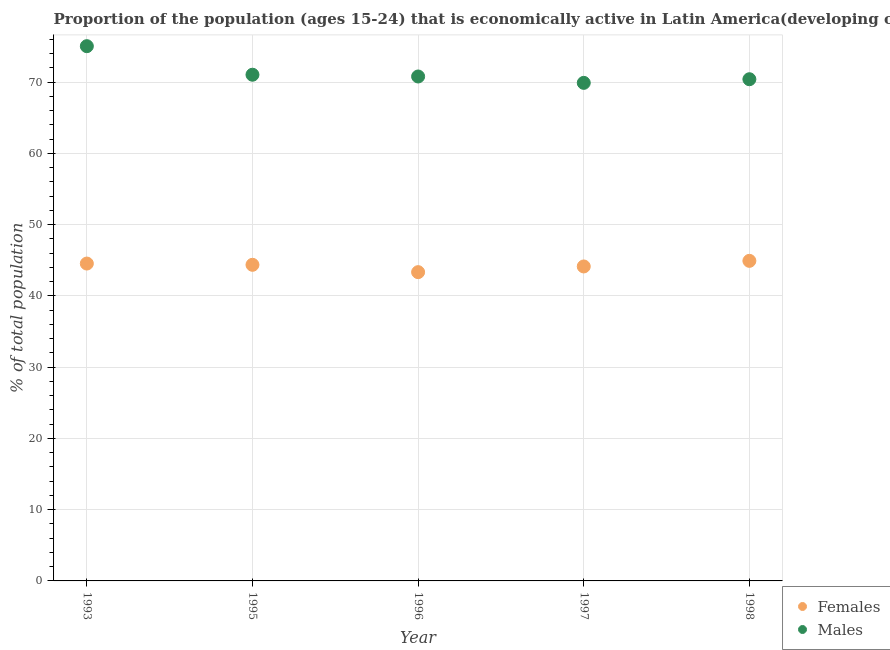How many different coloured dotlines are there?
Your response must be concise. 2. What is the percentage of economically active male population in 1998?
Provide a succinct answer. 70.42. Across all years, what is the maximum percentage of economically active female population?
Your response must be concise. 44.93. Across all years, what is the minimum percentage of economically active male population?
Make the answer very short. 69.91. In which year was the percentage of economically active female population maximum?
Keep it short and to the point. 1998. What is the total percentage of economically active male population in the graph?
Offer a terse response. 357.25. What is the difference between the percentage of economically active female population in 1995 and that in 1997?
Your answer should be very brief. 0.23. What is the difference between the percentage of economically active female population in 1993 and the percentage of economically active male population in 1998?
Your response must be concise. -25.87. What is the average percentage of economically active female population per year?
Your response must be concise. 44.27. In the year 1995, what is the difference between the percentage of economically active female population and percentage of economically active male population?
Your answer should be compact. -26.68. In how many years, is the percentage of economically active female population greater than 12 %?
Offer a terse response. 5. What is the ratio of the percentage of economically active female population in 1997 to that in 1998?
Provide a succinct answer. 0.98. Is the percentage of economically active female population in 1997 less than that in 1998?
Your answer should be very brief. Yes. Is the difference between the percentage of economically active male population in 1993 and 1998 greater than the difference between the percentage of economically active female population in 1993 and 1998?
Give a very brief answer. Yes. What is the difference between the highest and the second highest percentage of economically active male population?
Make the answer very short. 4.01. What is the difference between the highest and the lowest percentage of economically active male population?
Provide a succinct answer. 5.15. Is the sum of the percentage of economically active male population in 1993 and 1996 greater than the maximum percentage of economically active female population across all years?
Make the answer very short. Yes. How many years are there in the graph?
Provide a short and direct response. 5. Does the graph contain any zero values?
Your answer should be very brief. No. Where does the legend appear in the graph?
Give a very brief answer. Bottom right. How are the legend labels stacked?
Give a very brief answer. Vertical. What is the title of the graph?
Keep it short and to the point. Proportion of the population (ages 15-24) that is economically active in Latin America(developing only). Does "Crop" appear as one of the legend labels in the graph?
Give a very brief answer. No. What is the label or title of the Y-axis?
Give a very brief answer. % of total population. What is the % of total population of Females in 1993?
Ensure brevity in your answer.  44.55. What is the % of total population in Males in 1993?
Offer a very short reply. 75.06. What is the % of total population of Females in 1995?
Give a very brief answer. 44.37. What is the % of total population in Males in 1995?
Ensure brevity in your answer.  71.05. What is the % of total population of Females in 1996?
Ensure brevity in your answer.  43.34. What is the % of total population in Males in 1996?
Your answer should be compact. 70.8. What is the % of total population of Females in 1997?
Give a very brief answer. 44.14. What is the % of total population in Males in 1997?
Offer a very short reply. 69.91. What is the % of total population in Females in 1998?
Offer a very short reply. 44.93. What is the % of total population of Males in 1998?
Keep it short and to the point. 70.42. Across all years, what is the maximum % of total population of Females?
Make the answer very short. 44.93. Across all years, what is the maximum % of total population in Males?
Provide a succinct answer. 75.06. Across all years, what is the minimum % of total population of Females?
Ensure brevity in your answer.  43.34. Across all years, what is the minimum % of total population of Males?
Ensure brevity in your answer.  69.91. What is the total % of total population in Females in the graph?
Your response must be concise. 221.33. What is the total % of total population in Males in the graph?
Offer a very short reply. 357.25. What is the difference between the % of total population of Females in 1993 and that in 1995?
Make the answer very short. 0.18. What is the difference between the % of total population in Males in 1993 and that in 1995?
Your answer should be very brief. 4.01. What is the difference between the % of total population of Females in 1993 and that in 1996?
Your answer should be compact. 1.21. What is the difference between the % of total population of Males in 1993 and that in 1996?
Your answer should be compact. 4.25. What is the difference between the % of total population in Females in 1993 and that in 1997?
Keep it short and to the point. 0.41. What is the difference between the % of total population in Males in 1993 and that in 1997?
Offer a very short reply. 5.15. What is the difference between the % of total population of Females in 1993 and that in 1998?
Keep it short and to the point. -0.38. What is the difference between the % of total population of Males in 1993 and that in 1998?
Offer a terse response. 4.64. What is the difference between the % of total population of Females in 1995 and that in 1996?
Give a very brief answer. 1.03. What is the difference between the % of total population of Males in 1995 and that in 1996?
Your answer should be compact. 0.25. What is the difference between the % of total population of Females in 1995 and that in 1997?
Keep it short and to the point. 0.23. What is the difference between the % of total population of Males in 1995 and that in 1997?
Offer a terse response. 1.14. What is the difference between the % of total population in Females in 1995 and that in 1998?
Provide a short and direct response. -0.55. What is the difference between the % of total population of Males in 1995 and that in 1998?
Offer a terse response. 0.63. What is the difference between the % of total population of Females in 1996 and that in 1997?
Your answer should be very brief. -0.8. What is the difference between the % of total population in Males in 1996 and that in 1997?
Make the answer very short. 0.9. What is the difference between the % of total population of Females in 1996 and that in 1998?
Make the answer very short. -1.58. What is the difference between the % of total population of Males in 1996 and that in 1998?
Provide a short and direct response. 0.38. What is the difference between the % of total population of Females in 1997 and that in 1998?
Your answer should be compact. -0.79. What is the difference between the % of total population of Males in 1997 and that in 1998?
Make the answer very short. -0.51. What is the difference between the % of total population of Females in 1993 and the % of total population of Males in 1995?
Your answer should be compact. -26.5. What is the difference between the % of total population of Females in 1993 and the % of total population of Males in 1996?
Ensure brevity in your answer.  -26.26. What is the difference between the % of total population in Females in 1993 and the % of total population in Males in 1997?
Your answer should be very brief. -25.36. What is the difference between the % of total population of Females in 1993 and the % of total population of Males in 1998?
Make the answer very short. -25.87. What is the difference between the % of total population of Females in 1995 and the % of total population of Males in 1996?
Make the answer very short. -26.43. What is the difference between the % of total population of Females in 1995 and the % of total population of Males in 1997?
Make the answer very short. -25.54. What is the difference between the % of total population of Females in 1995 and the % of total population of Males in 1998?
Your answer should be compact. -26.05. What is the difference between the % of total population in Females in 1996 and the % of total population in Males in 1997?
Provide a short and direct response. -26.57. What is the difference between the % of total population of Females in 1996 and the % of total population of Males in 1998?
Your response must be concise. -27.08. What is the difference between the % of total population of Females in 1997 and the % of total population of Males in 1998?
Provide a short and direct response. -26.28. What is the average % of total population of Females per year?
Provide a short and direct response. 44.27. What is the average % of total population of Males per year?
Ensure brevity in your answer.  71.45. In the year 1993, what is the difference between the % of total population of Females and % of total population of Males?
Provide a succinct answer. -30.51. In the year 1995, what is the difference between the % of total population of Females and % of total population of Males?
Provide a succinct answer. -26.68. In the year 1996, what is the difference between the % of total population in Females and % of total population in Males?
Your answer should be compact. -27.46. In the year 1997, what is the difference between the % of total population of Females and % of total population of Males?
Make the answer very short. -25.77. In the year 1998, what is the difference between the % of total population in Females and % of total population in Males?
Offer a very short reply. -25.49. What is the ratio of the % of total population of Males in 1993 to that in 1995?
Give a very brief answer. 1.06. What is the ratio of the % of total population in Females in 1993 to that in 1996?
Your answer should be compact. 1.03. What is the ratio of the % of total population in Males in 1993 to that in 1996?
Keep it short and to the point. 1.06. What is the ratio of the % of total population of Females in 1993 to that in 1997?
Ensure brevity in your answer.  1.01. What is the ratio of the % of total population of Males in 1993 to that in 1997?
Your answer should be very brief. 1.07. What is the ratio of the % of total population of Males in 1993 to that in 1998?
Your answer should be compact. 1.07. What is the ratio of the % of total population of Females in 1995 to that in 1996?
Make the answer very short. 1.02. What is the ratio of the % of total population of Males in 1995 to that in 1996?
Your response must be concise. 1. What is the ratio of the % of total population in Males in 1995 to that in 1997?
Your answer should be compact. 1.02. What is the ratio of the % of total population in Females in 1995 to that in 1998?
Provide a succinct answer. 0.99. What is the ratio of the % of total population of Males in 1995 to that in 1998?
Your response must be concise. 1.01. What is the ratio of the % of total population in Females in 1996 to that in 1997?
Your answer should be compact. 0.98. What is the ratio of the % of total population of Males in 1996 to that in 1997?
Give a very brief answer. 1.01. What is the ratio of the % of total population of Females in 1996 to that in 1998?
Provide a short and direct response. 0.96. What is the ratio of the % of total population in Females in 1997 to that in 1998?
Give a very brief answer. 0.98. What is the ratio of the % of total population in Males in 1997 to that in 1998?
Ensure brevity in your answer.  0.99. What is the difference between the highest and the second highest % of total population in Females?
Offer a terse response. 0.38. What is the difference between the highest and the second highest % of total population in Males?
Your response must be concise. 4.01. What is the difference between the highest and the lowest % of total population of Females?
Ensure brevity in your answer.  1.58. What is the difference between the highest and the lowest % of total population of Males?
Offer a terse response. 5.15. 